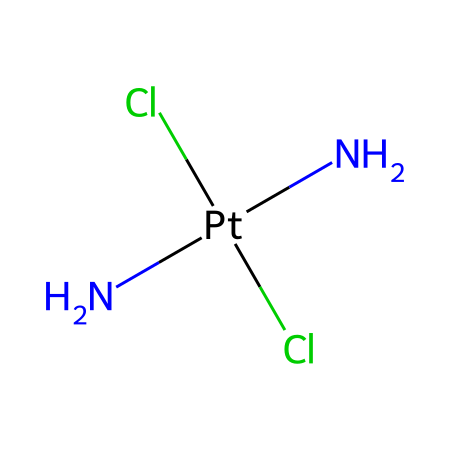How many chlorine atoms are present in this molecule? The SMILES representation shows two 'Cl' symbols, indicating that there are two chlorine atoms in the structure. Each 'Cl' represents one chlorine atom.
Answer: 2 What is the central metal in cisplatin? The SMILES indicates 'Pt' as the central atom, which is the symbol for platinum. In organometallics, the metal is often the central component.
Answer: platinum How many nitrogen atoms are connected to the platinum atom? The 'N' symbols in the SMILES represent nitrogen atoms. There are two 'N' symbols connected to the platinum atom, indicating that two nitrogen atoms are attached to it.
Answer: 2 What type of coordination does cisplatin exhibit? The chemical structure reveals that platinum is coordinated by two nitrogen atoms and two chlorine atoms, leading to a square planar geometry, which is characteristic of many organometallic complexes.
Answer: square planar Which chemical feature contributes to the anticancer property of cisplatin? The presence of the platinum atom and its ability to form cross-links with DNA through its reactive sites, specifically through the nitrogen atoms, plays a crucial role in its efficacy as an anticancer drug.
Answer: platinum What type of chemical compound is cisplatin classified as? Given its structure, which includes a metal center (platinum) and organic ligands (nitrogen and chlorine), cisplatin is classified as an organometallic anticancer compound.
Answer: organometallic How does the geometry of cisplatin affect its mechanism of action? The square planar geometry of cisplatin allows it to effectively interact with DNA by forming cross-links between DNA strands, which interferes with replication and transcription processes, essential for cancer cell proliferation.
Answer: affects DNA interaction 